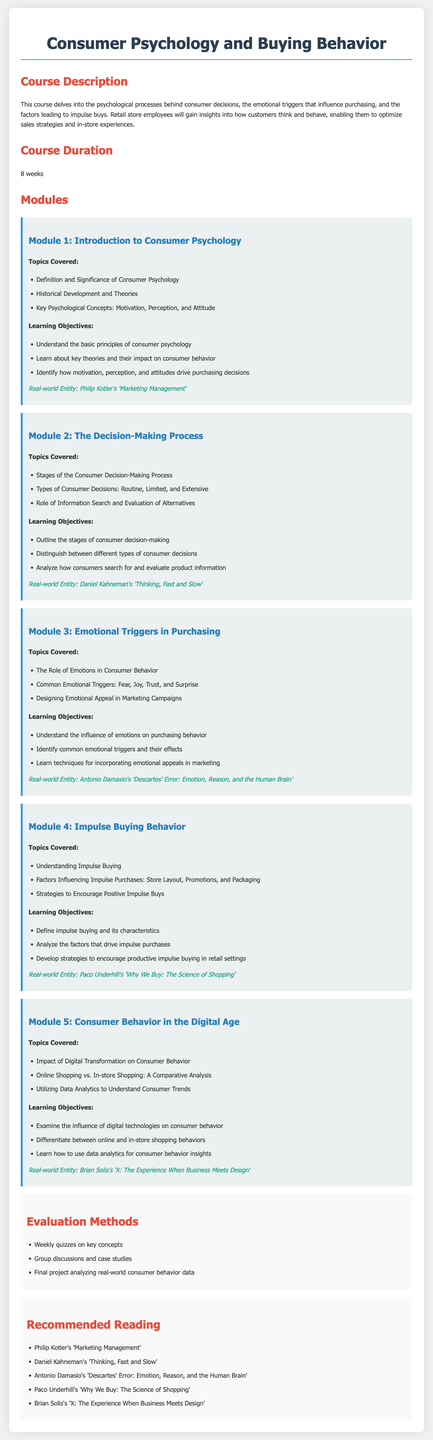what is the course duration? The course duration is explicitly stated in the syllabus as 8 weeks.
Answer: 8 weeks what is the title of Module 3? The title of Module 3 is mentioned clearly in the syllabus, focusing on emotional aspects in purchasing.
Answer: Emotional Triggers in Purchasing who is the author of 'Thinking, Fast and Slow'? The syllabus includes the names of the authors for each real-world entity, and Daniel Kahneman is attributed to this book.
Answer: Daniel Kahneman what is one method of evaluation listed in the syllabus? The syllabus lists various evaluation methods, and one of them is weekly quizzes.
Answer: Weekly quizzes what are the key psychological concepts covered in Module 1? The syllabus highlights specific concepts within the context of consumer psychology for Module 1.
Answer: Motivation, Perception, and Attitude how many modules are in this syllabus? By counting the modules outlined in the syllabus, we can find the total number.
Answer: 5 modules what is the real-world entity associated with impulse buying behavior? Each module in the syllabus has a corresponding real-world entity, and for impulse buying behavior, it's mentioned clearly.
Answer: Paco Underhill's 'Why We Buy: The Science of Shopping' what type of consumer decisions are discussed in Module 2? Module 2 highlights different classifications of consumer decisions, as indicated in the syllabus.
Answer: Routine, Limited, and Extensive 